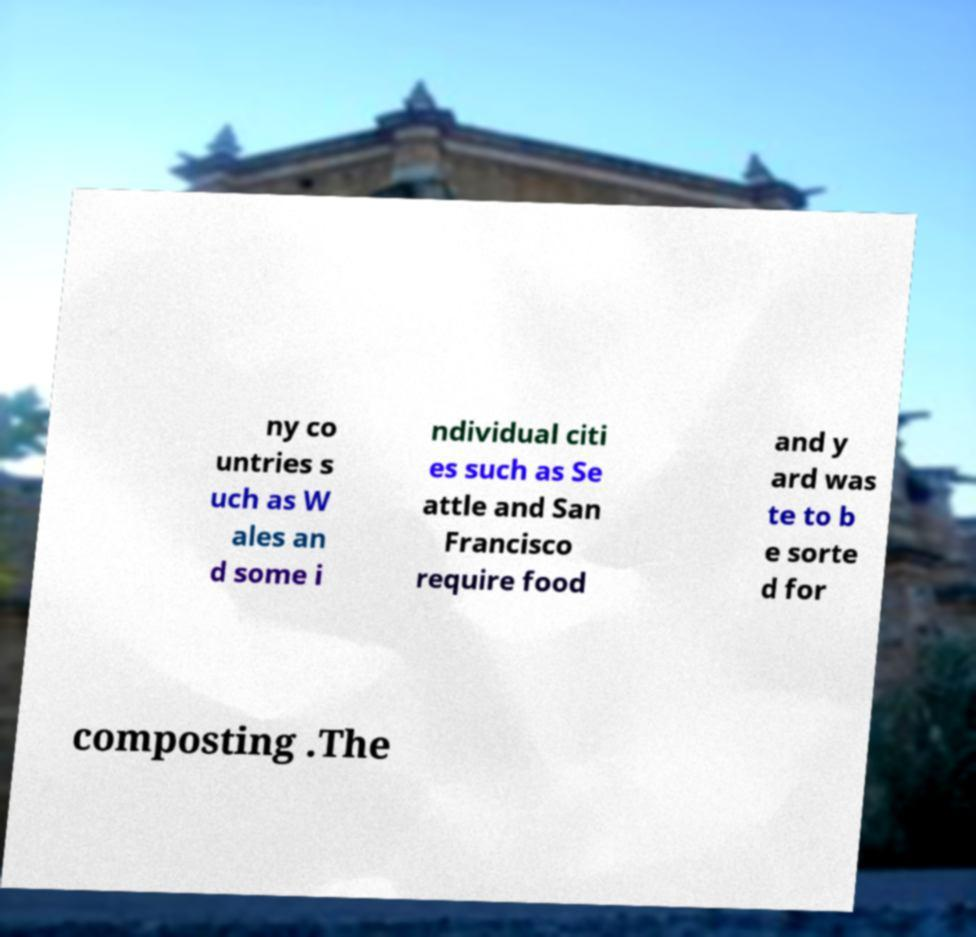Could you assist in decoding the text presented in this image and type it out clearly? ny co untries s uch as W ales an d some i ndividual citi es such as Se attle and San Francisco require food and y ard was te to b e sorte d for composting .The 